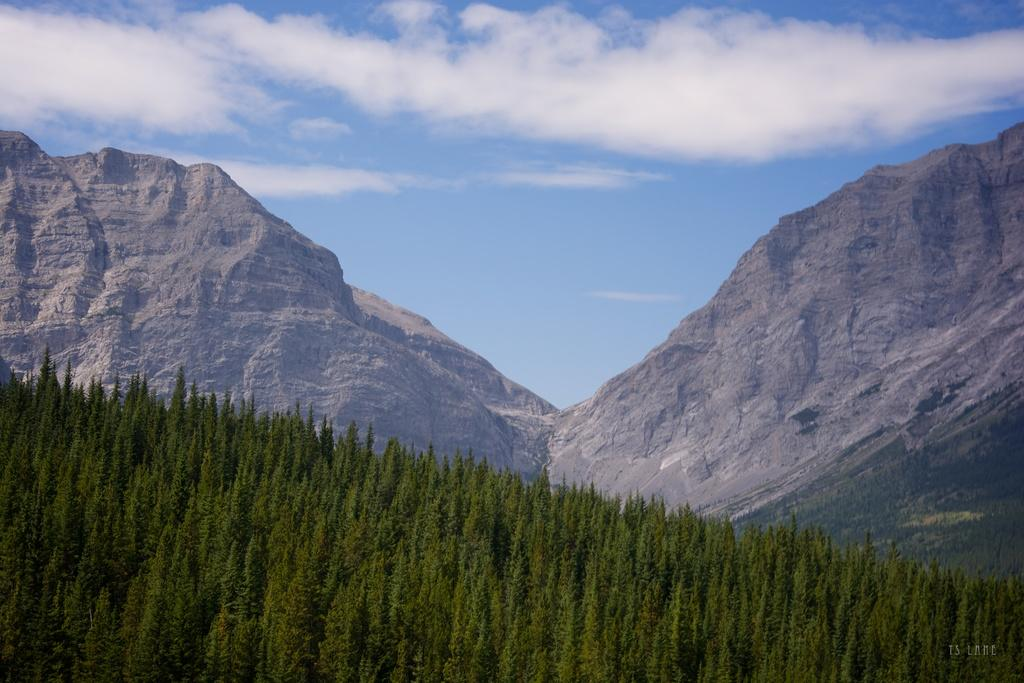What type of vegetation can be seen in the image? There are trees in the image. What geographical feature is visible in the image? There is a mountain in the image. What part of the natural environment is visible in the image? The sky is visible in the background of the image. What can be seen in the sky in the image? Clouds are present in the sky. How many celery stalks can be seen growing near the mountain in the image? There is no celery present in the image. Can you describe the snails crawling on the trees in the image? There are no snails visible on the trees in the image. 